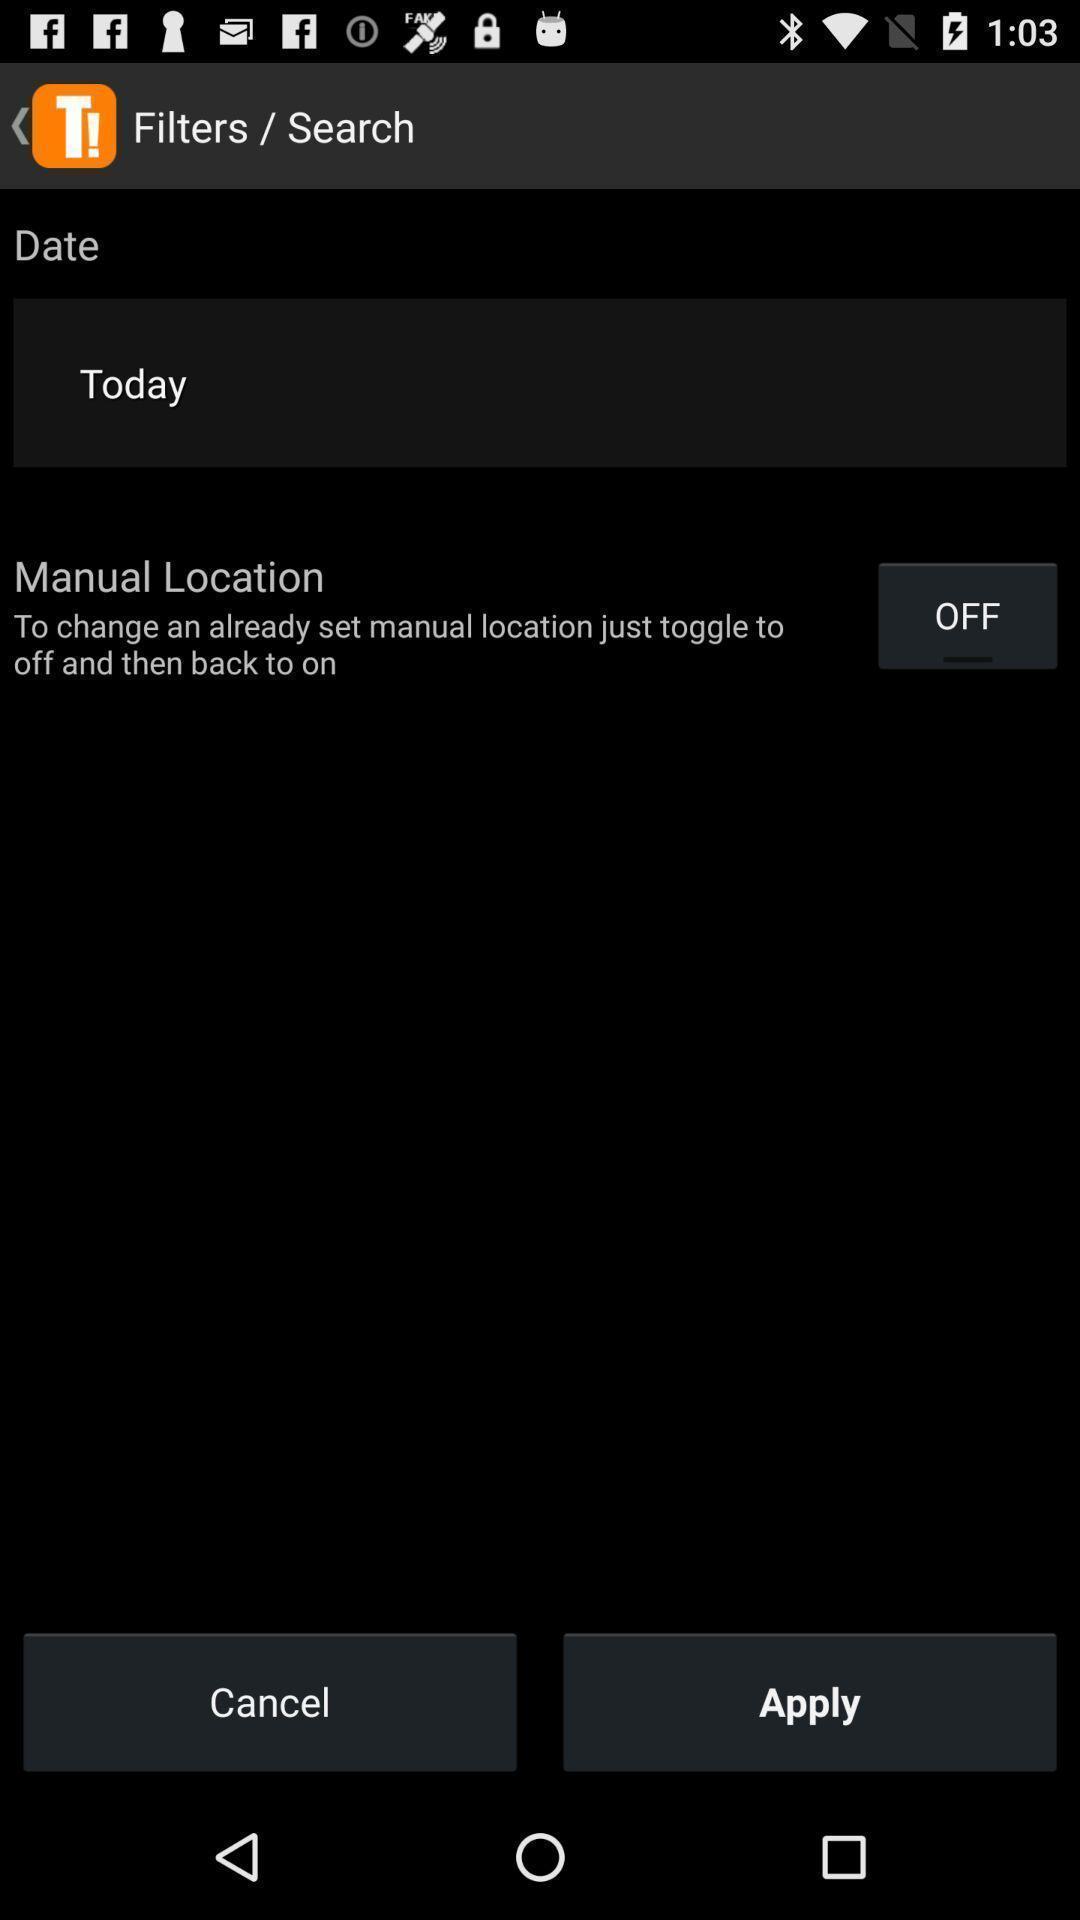Provide a description of this screenshot. Screen showing filters/search page with date. 